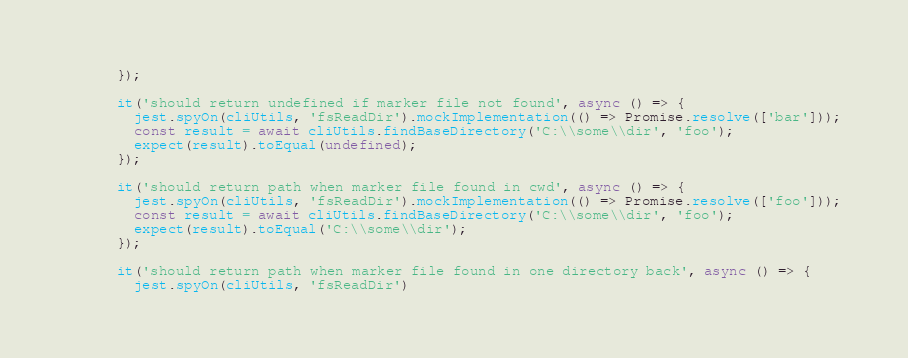<code> <loc_0><loc_0><loc_500><loc_500><_TypeScript_>      });

      it('should return undefined if marker file not found', async () => {
        jest.spyOn(cliUtils, 'fsReadDir').mockImplementation(() => Promise.resolve(['bar']));
        const result = await cliUtils.findBaseDirectory('C:\\some\\dir', 'foo');
        expect(result).toEqual(undefined);
      });

      it('should return path when marker file found in cwd', async () => {
        jest.spyOn(cliUtils, 'fsReadDir').mockImplementation(() => Promise.resolve(['foo']));
        const result = await cliUtils.findBaseDirectory('C:\\some\\dir', 'foo');
        expect(result).toEqual('C:\\some\\dir');
      });

      it('should return path when marker file found in one directory back', async () => {
        jest.spyOn(cliUtils, 'fsReadDir')</code> 